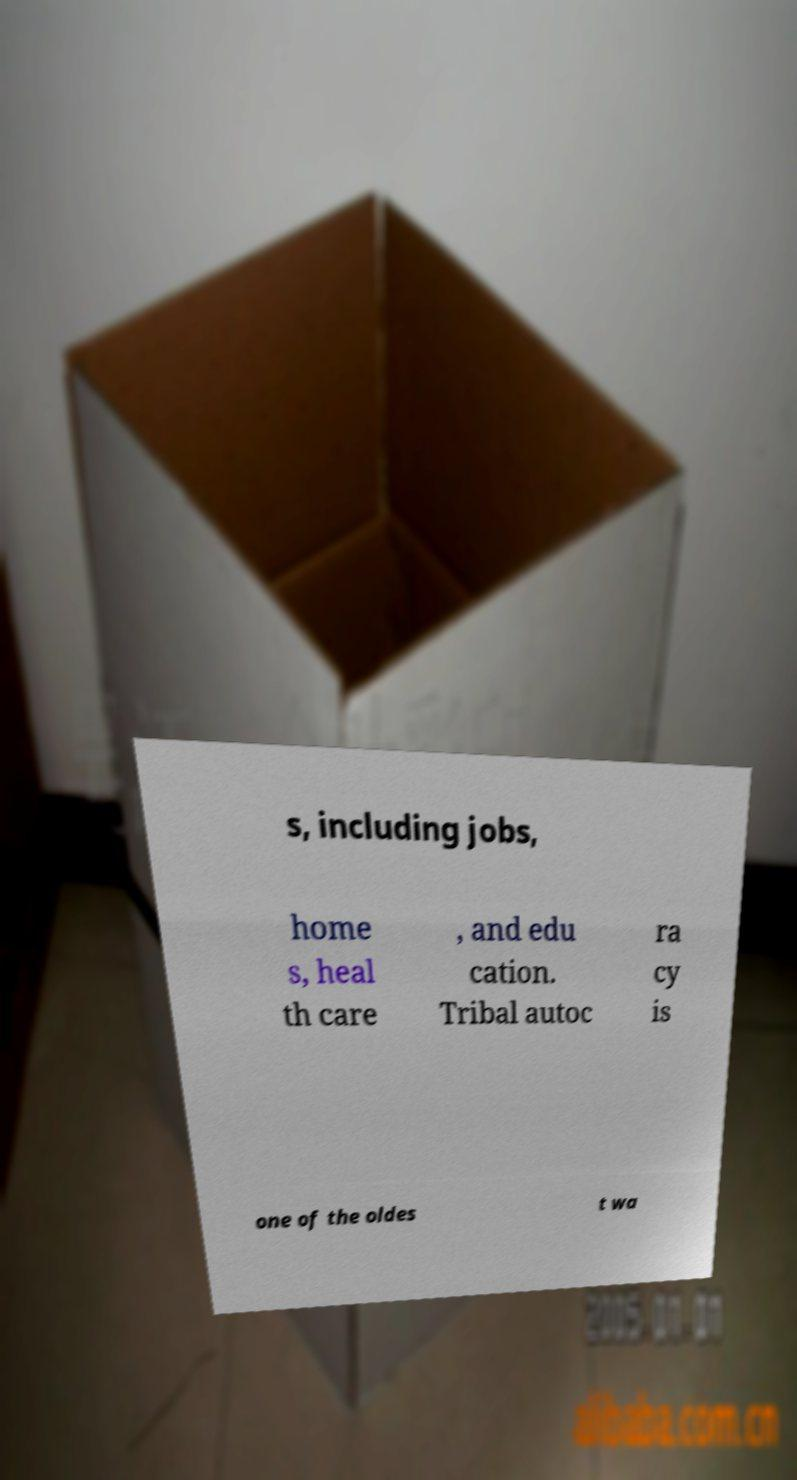Could you extract and type out the text from this image? s, including jobs, home s, heal th care , and edu cation. Tribal autoc ra cy is one of the oldes t wa 